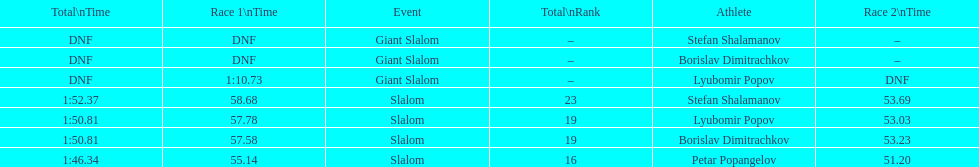Which athlete had a race time above 1:00? Lyubomir Popov. 